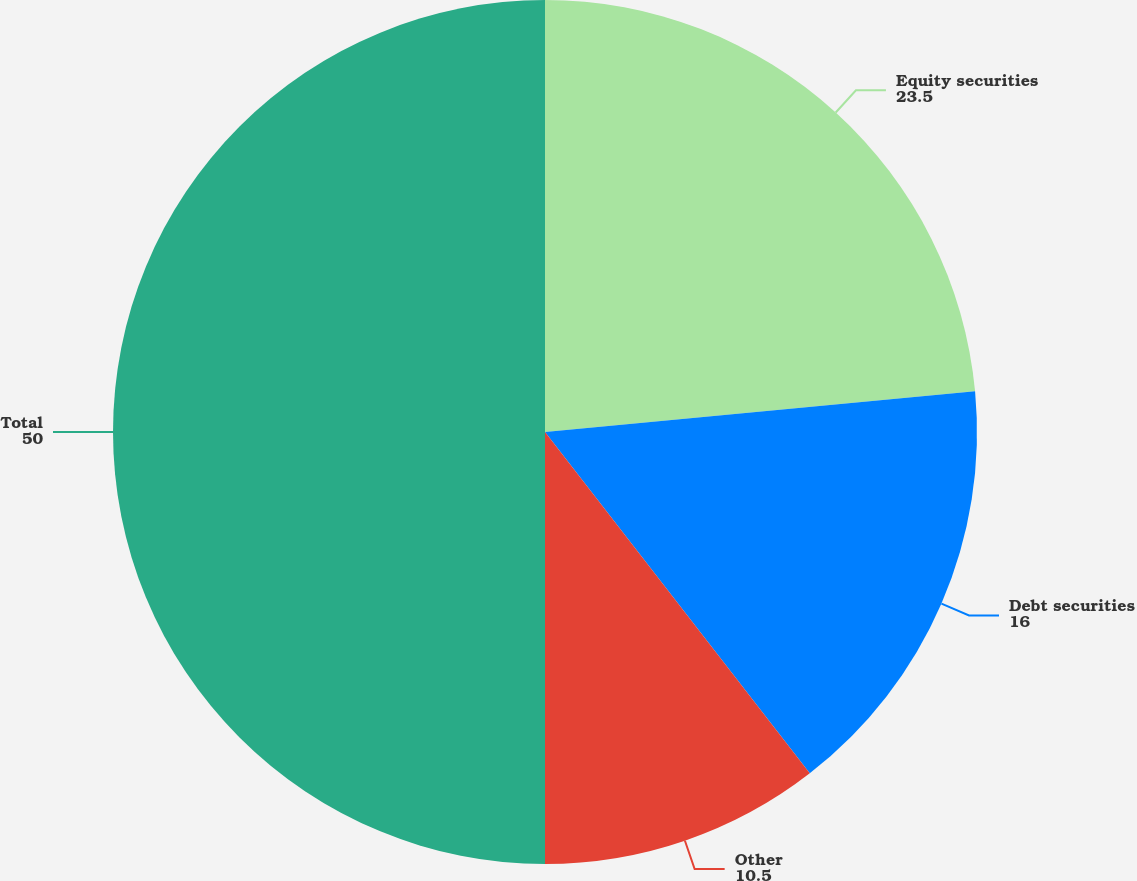Convert chart to OTSL. <chart><loc_0><loc_0><loc_500><loc_500><pie_chart><fcel>Equity securities<fcel>Debt securities<fcel>Other<fcel>Total<nl><fcel>23.5%<fcel>16.0%<fcel>10.5%<fcel>50.0%<nl></chart> 